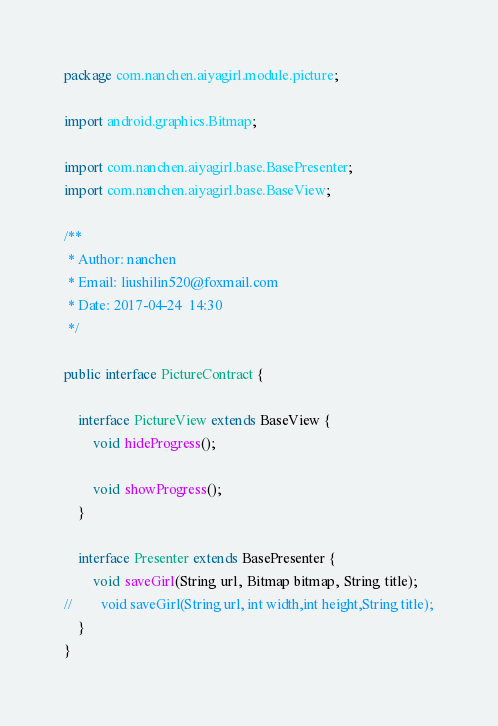<code> <loc_0><loc_0><loc_500><loc_500><_Java_>package com.nanchen.aiyagirl.module.picture;

import android.graphics.Bitmap;

import com.nanchen.aiyagirl.base.BasePresenter;
import com.nanchen.aiyagirl.base.BaseView;

/**
 * Author: nanchen
 * Email: liushilin520@foxmail.com
 * Date: 2017-04-24  14:30
 */

public interface PictureContract {

    interface PictureView extends BaseView {
        void hideProgress();

        void showProgress();
    }

    interface Presenter extends BasePresenter {
        void saveGirl(String url, Bitmap bitmap, String title);
//        void saveGirl(String url, int width,int height,String title);
    }
}
</code> 